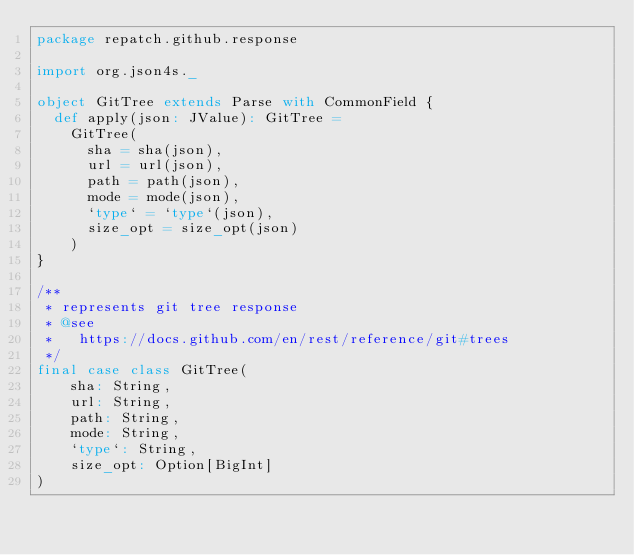Convert code to text. <code><loc_0><loc_0><loc_500><loc_500><_Scala_>package repatch.github.response

import org.json4s._

object GitTree extends Parse with CommonField {
  def apply(json: JValue): GitTree =
    GitTree(
      sha = sha(json),
      url = url(json),
      path = path(json),
      mode = mode(json),
      `type` = `type`(json),
      size_opt = size_opt(json)
    )
}

/**
 * represents git tree response
 * @see
 *   https://docs.github.com/en/rest/reference/git#trees
 */
final case class GitTree(
    sha: String,
    url: String,
    path: String,
    mode: String,
    `type`: String,
    size_opt: Option[BigInt]
)
</code> 